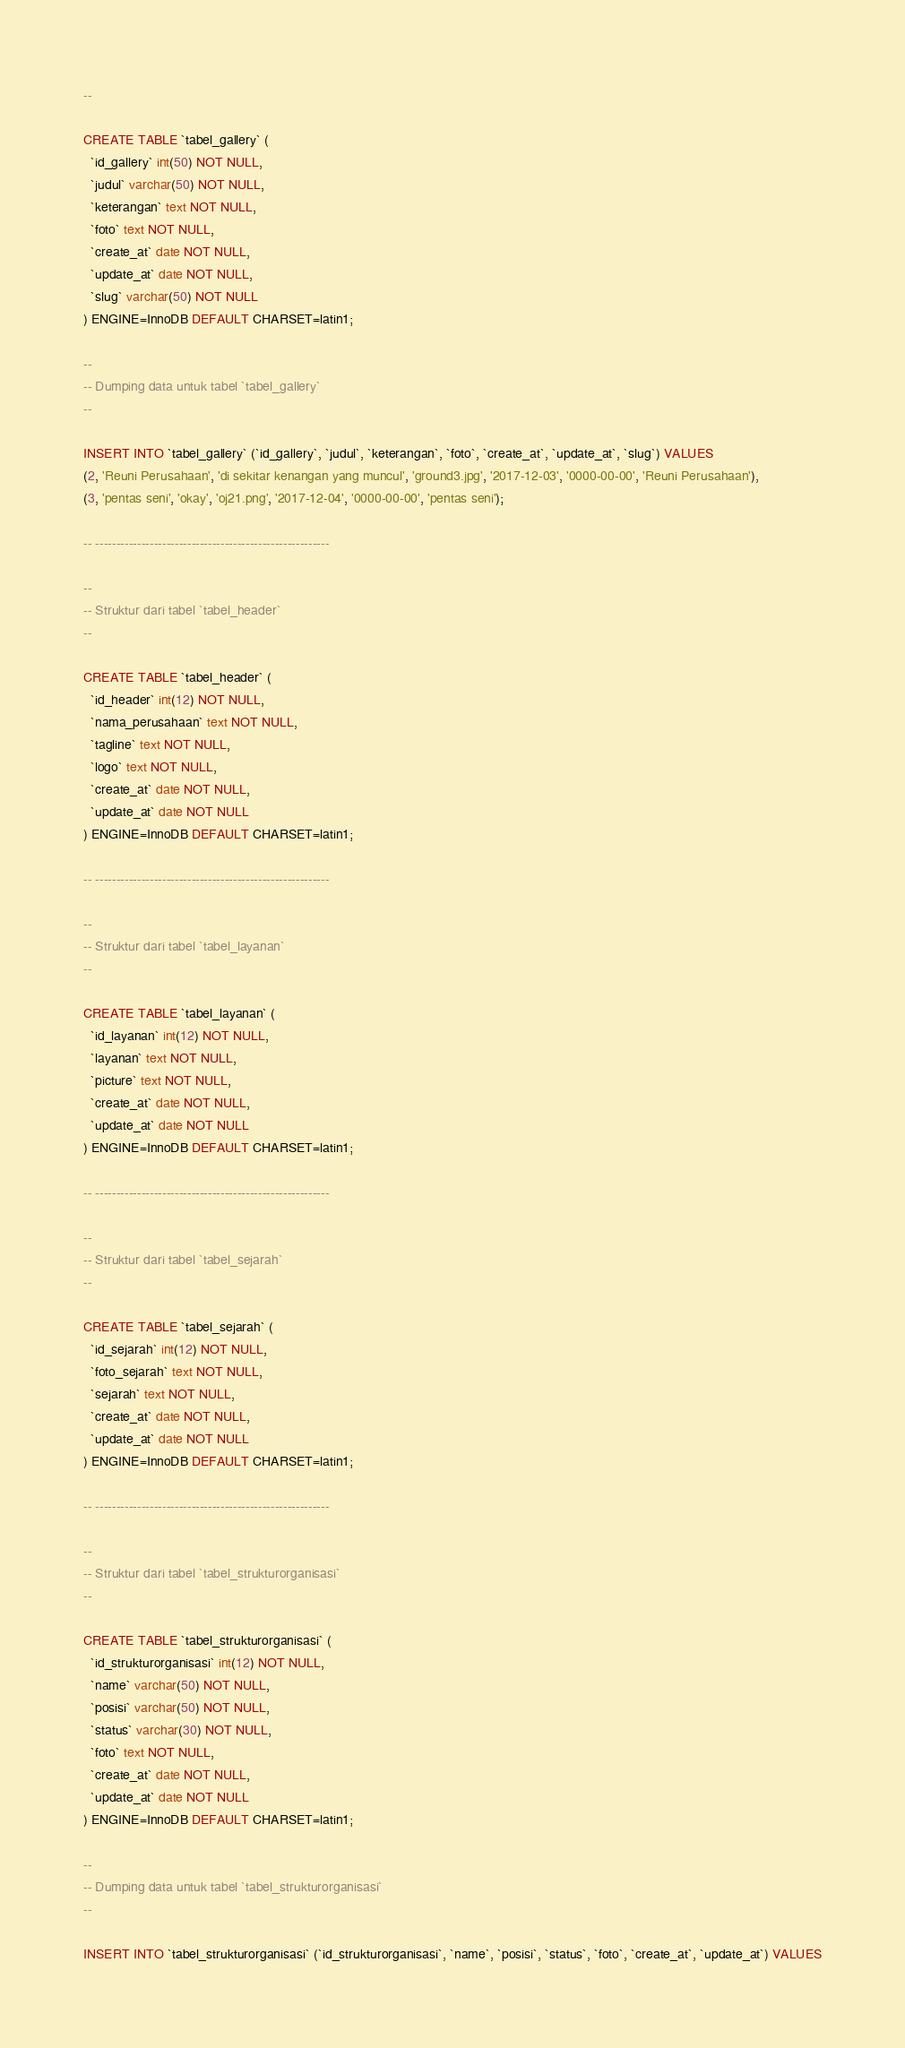Convert code to text. <code><loc_0><loc_0><loc_500><loc_500><_SQL_>--

CREATE TABLE `tabel_gallery` (
  `id_gallery` int(50) NOT NULL,
  `judul` varchar(50) NOT NULL,
  `keterangan` text NOT NULL,
  `foto` text NOT NULL,
  `create_at` date NOT NULL,
  `update_at` date NOT NULL,
  `slug` varchar(50) NOT NULL
) ENGINE=InnoDB DEFAULT CHARSET=latin1;

--
-- Dumping data untuk tabel `tabel_gallery`
--

INSERT INTO `tabel_gallery` (`id_gallery`, `judul`, `keterangan`, `foto`, `create_at`, `update_at`, `slug`) VALUES
(2, 'Reuni Perusahaan', 'di sekitar kenangan yang muncul', 'ground3.jpg', '2017-12-03', '0000-00-00', 'Reuni Perusahaan'),
(3, 'pentas seni', 'okay', 'oj21.png', '2017-12-04', '0000-00-00', 'pentas seni');

-- --------------------------------------------------------

--
-- Struktur dari tabel `tabel_header`
--

CREATE TABLE `tabel_header` (
  `id_header` int(12) NOT NULL,
  `nama_perusahaan` text NOT NULL,
  `tagline` text NOT NULL,
  `logo` text NOT NULL,
  `create_at` date NOT NULL,
  `update_at` date NOT NULL
) ENGINE=InnoDB DEFAULT CHARSET=latin1;

-- --------------------------------------------------------

--
-- Struktur dari tabel `tabel_layanan`
--

CREATE TABLE `tabel_layanan` (
  `id_layanan` int(12) NOT NULL,
  `layanan` text NOT NULL,
  `picture` text NOT NULL,
  `create_at` date NOT NULL,
  `update_at` date NOT NULL
) ENGINE=InnoDB DEFAULT CHARSET=latin1;

-- --------------------------------------------------------

--
-- Struktur dari tabel `tabel_sejarah`
--

CREATE TABLE `tabel_sejarah` (
  `id_sejarah` int(12) NOT NULL,
  `foto_sejarah` text NOT NULL,
  `sejarah` text NOT NULL,
  `create_at` date NOT NULL,
  `update_at` date NOT NULL
) ENGINE=InnoDB DEFAULT CHARSET=latin1;

-- --------------------------------------------------------

--
-- Struktur dari tabel `tabel_strukturorganisasi`
--

CREATE TABLE `tabel_strukturorganisasi` (
  `id_strukturorganisasi` int(12) NOT NULL,
  `name` varchar(50) NOT NULL,
  `posisi` varchar(50) NOT NULL,
  `status` varchar(30) NOT NULL,
  `foto` text NOT NULL,
  `create_at` date NOT NULL,
  `update_at` date NOT NULL
) ENGINE=InnoDB DEFAULT CHARSET=latin1;

--
-- Dumping data untuk tabel `tabel_strukturorganisasi`
--

INSERT INTO `tabel_strukturorganisasi` (`id_strukturorganisasi`, `name`, `posisi`, `status`, `foto`, `create_at`, `update_at`) VALUES</code> 